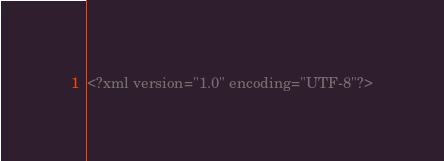Convert code to text. <code><loc_0><loc_0><loc_500><loc_500><_XML_><?xml version="1.0" encoding="UTF-8"?></code> 